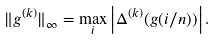<formula> <loc_0><loc_0><loc_500><loc_500>\| g ^ { ( k ) } \| _ { \infty } = \max _ { i } \left | \Delta ^ { ( k ) } ( g ( i / n ) ) \right | .</formula> 